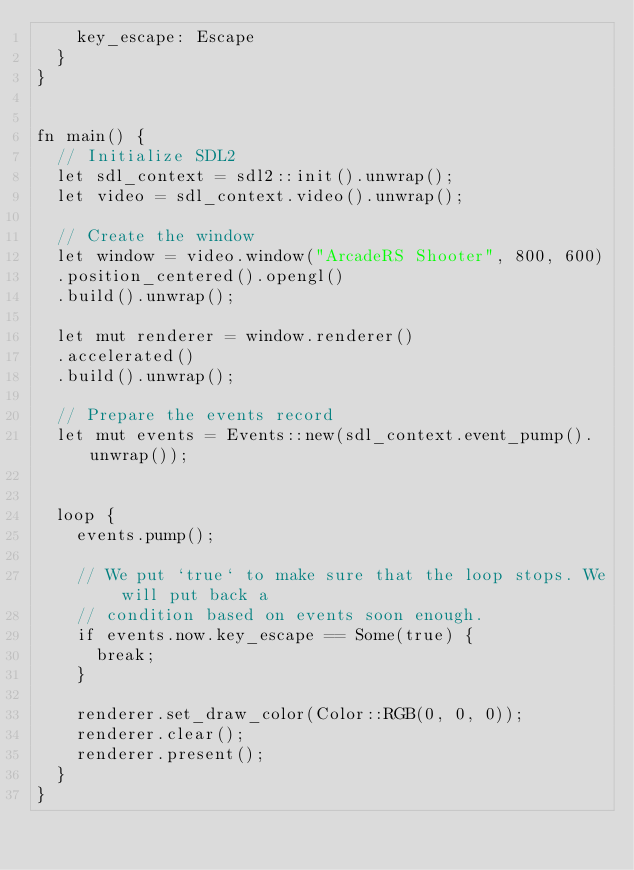<code> <loc_0><loc_0><loc_500><loc_500><_Rust_>    key_escape: Escape
  }
}


fn main() {
  // Initialize SDL2
  let sdl_context = sdl2::init().unwrap();
  let video = sdl_context.video().unwrap();

  // Create the window
  let window = video.window("ArcadeRS Shooter", 800, 600)
  .position_centered().opengl()
  .build().unwrap();

  let mut renderer = window.renderer()
  .accelerated()
  .build().unwrap();

  // Prepare the events record
  let mut events = Events::new(sdl_context.event_pump().unwrap());


  loop {
    events.pump();

    // We put `true` to make sure that the loop stops. We will put back a
    // condition based on events soon enough.
    if events.now.key_escape == Some(true) {
      break;
    }

    renderer.set_draw_color(Color::RGB(0, 0, 0));
    renderer.clear();
    renderer.present();
  }
}</code> 